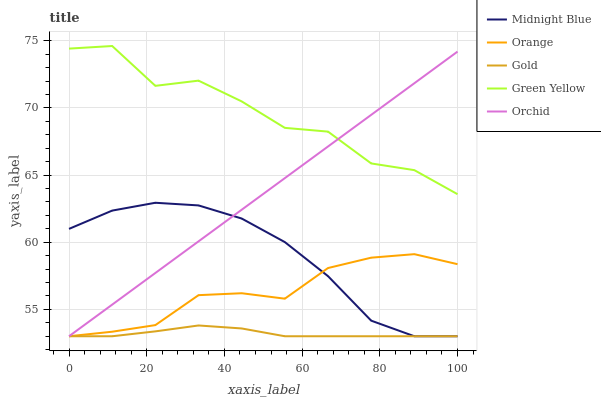Does Gold have the minimum area under the curve?
Answer yes or no. Yes. Does Green Yellow have the maximum area under the curve?
Answer yes or no. Yes. Does Midnight Blue have the minimum area under the curve?
Answer yes or no. No. Does Midnight Blue have the maximum area under the curve?
Answer yes or no. No. Is Orchid the smoothest?
Answer yes or no. Yes. Is Green Yellow the roughest?
Answer yes or no. Yes. Is Midnight Blue the smoothest?
Answer yes or no. No. Is Midnight Blue the roughest?
Answer yes or no. No. Does Green Yellow have the lowest value?
Answer yes or no. No. Does Green Yellow have the highest value?
Answer yes or no. Yes. Does Midnight Blue have the highest value?
Answer yes or no. No. Is Midnight Blue less than Green Yellow?
Answer yes or no. Yes. Is Green Yellow greater than Gold?
Answer yes or no. Yes. Does Midnight Blue intersect Green Yellow?
Answer yes or no. No. 